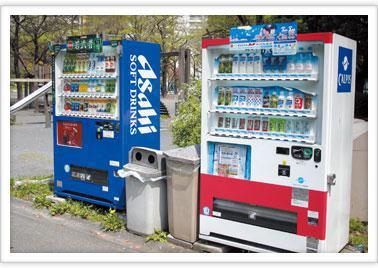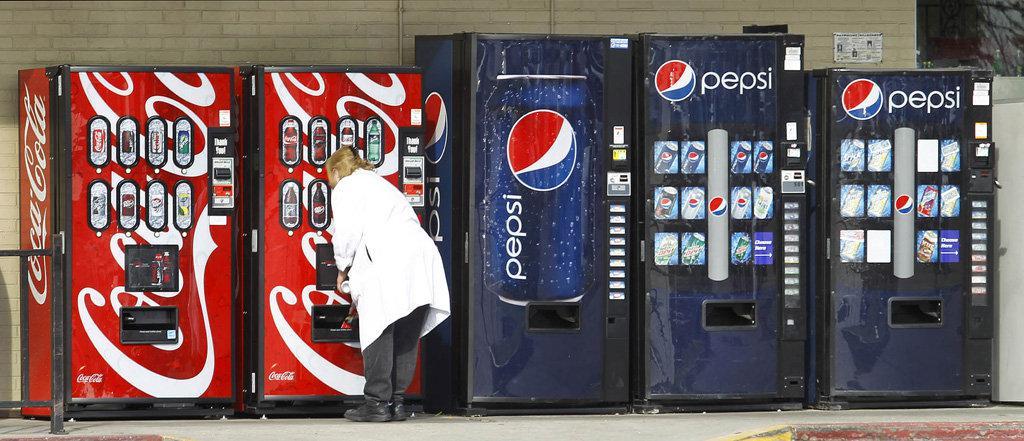The first image is the image on the left, the second image is the image on the right. For the images shown, is this caption "There's the same number of vending machines in each image." true? Answer yes or no. No. The first image is the image on the left, the second image is the image on the right. For the images shown, is this caption "The left image contains no more than two vending machines." true? Answer yes or no. Yes. 